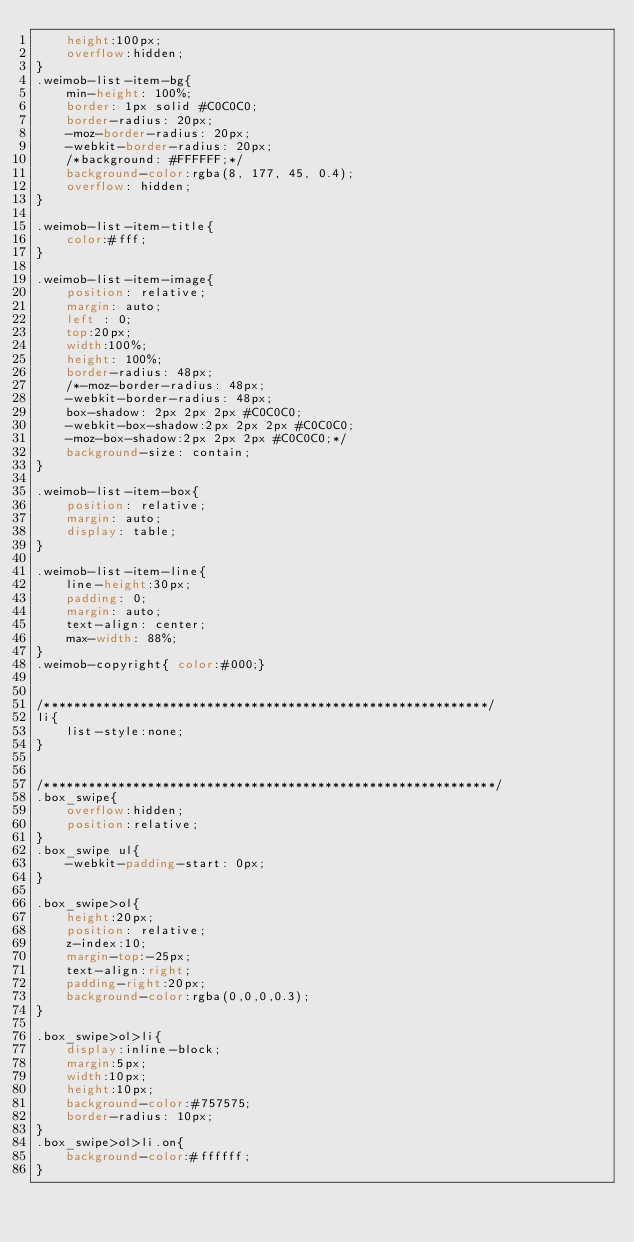Convert code to text. <code><loc_0><loc_0><loc_500><loc_500><_CSS_>    height:100px;
    overflow:hidden;
}
.weimob-list-item-bg{
    min-height: 100%;
    border: 1px solid #C0C0C0;
    border-radius: 20px;
    -moz-border-radius: 20px;
    -webkit-border-radius: 20px;
    /*background: #FFFFFF;*/
    background-color:rgba(8, 177, 45, 0.4);
    overflow: hidden;
}

.weimob-list-item-title{
    color:#fff;
}

.weimob-list-item-image{
    position: relative;
    margin: auto;
    left : 0;
    top:20px;
    width:100%;
    height: 100%;
    border-radius: 48px;
    /*-moz-border-radius: 48px;
    -webkit-border-radius: 48px;
    box-shadow: 2px 2px 2px #C0C0C0;
    -webkit-box-shadow:2px 2px 2px #C0C0C0;
    -moz-box-shadow:2px 2px 2px #C0C0C0;*/
    background-size: contain;
}

.weimob-list-item-box{
    position: relative;
    margin: auto;
    display: table;
}

.weimob-list-item-line{
    line-height:30px;
    padding: 0;
    margin: auto;
    text-align: center;
    max-width: 88%;
}
.weimob-copyright{ color:#000;}


/************************************************************/
li{
    list-style:none;
}


/*************************************************************/
.box_swipe{
    overflow:hidden;
    position:relative;
}
.box_swipe ul{
    -webkit-padding-start: 0px;
}

.box_swipe>ol{
    height:20px;
    position: relative;
    z-index:10;
    margin-top:-25px;
    text-align:right;
    padding-right:20px;
    background-color:rgba(0,0,0,0.3);
}

.box_swipe>ol>li{
    display:inline-block;
    margin:5px;
    width:10px;
    height:10px;
    background-color:#757575;
    border-radius: 10px;
}
.box_swipe>ol>li.on{
    background-color:#ffffff;
}</code> 